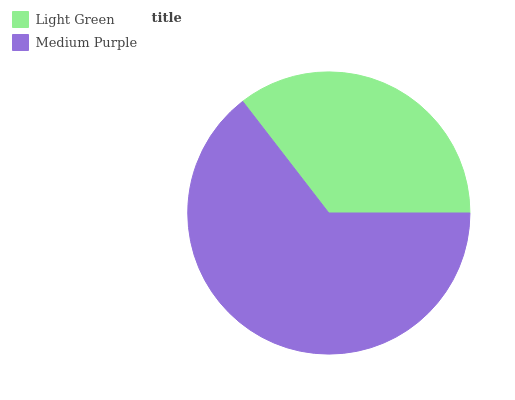Is Light Green the minimum?
Answer yes or no. Yes. Is Medium Purple the maximum?
Answer yes or no. Yes. Is Medium Purple the minimum?
Answer yes or no. No. Is Medium Purple greater than Light Green?
Answer yes or no. Yes. Is Light Green less than Medium Purple?
Answer yes or no. Yes. Is Light Green greater than Medium Purple?
Answer yes or no. No. Is Medium Purple less than Light Green?
Answer yes or no. No. Is Medium Purple the high median?
Answer yes or no. Yes. Is Light Green the low median?
Answer yes or no. Yes. Is Light Green the high median?
Answer yes or no. No. Is Medium Purple the low median?
Answer yes or no. No. 